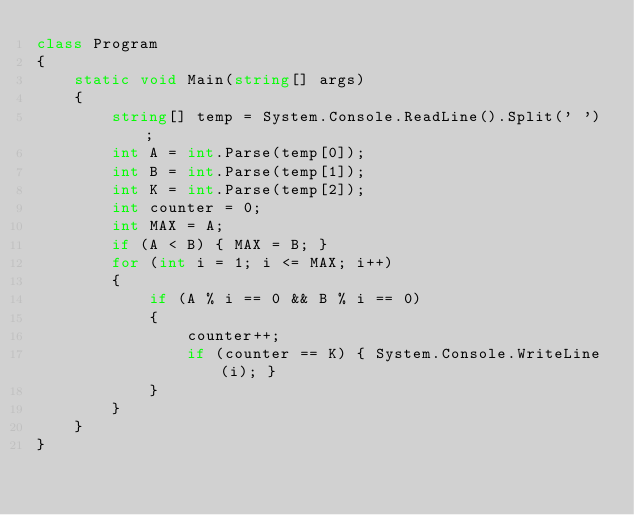Convert code to text. <code><loc_0><loc_0><loc_500><loc_500><_C#_>class Program
{
    static void Main(string[] args)
    {
        string[] temp = System.Console.ReadLine().Split(' ');
        int A = int.Parse(temp[0]);
        int B = int.Parse(temp[1]);
        int K = int.Parse(temp[2]);
        int counter = 0;
        int MAX = A;
        if (A < B) { MAX = B; }
        for (int i = 1; i <= MAX; i++)
        {
            if (A % i == 0 && B % i == 0)
            {
                counter++;
                if (counter == K) { System.Console.WriteLine(i); }
            }
        }
    }
}
</code> 